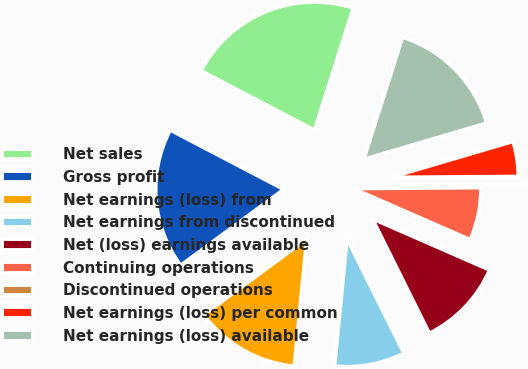Convert chart to OTSL. <chart><loc_0><loc_0><loc_500><loc_500><pie_chart><fcel>Net sales<fcel>Gross profit<fcel>Net earnings (loss) from<fcel>Net earnings from discontinued<fcel>Net (loss) earnings available<fcel>Continuing operations<fcel>Discontinued operations<fcel>Net earnings (loss) per common<fcel>Net earnings (loss) available<nl><fcel>22.22%<fcel>17.78%<fcel>13.33%<fcel>8.89%<fcel>11.11%<fcel>6.67%<fcel>0.0%<fcel>4.44%<fcel>15.56%<nl></chart> 